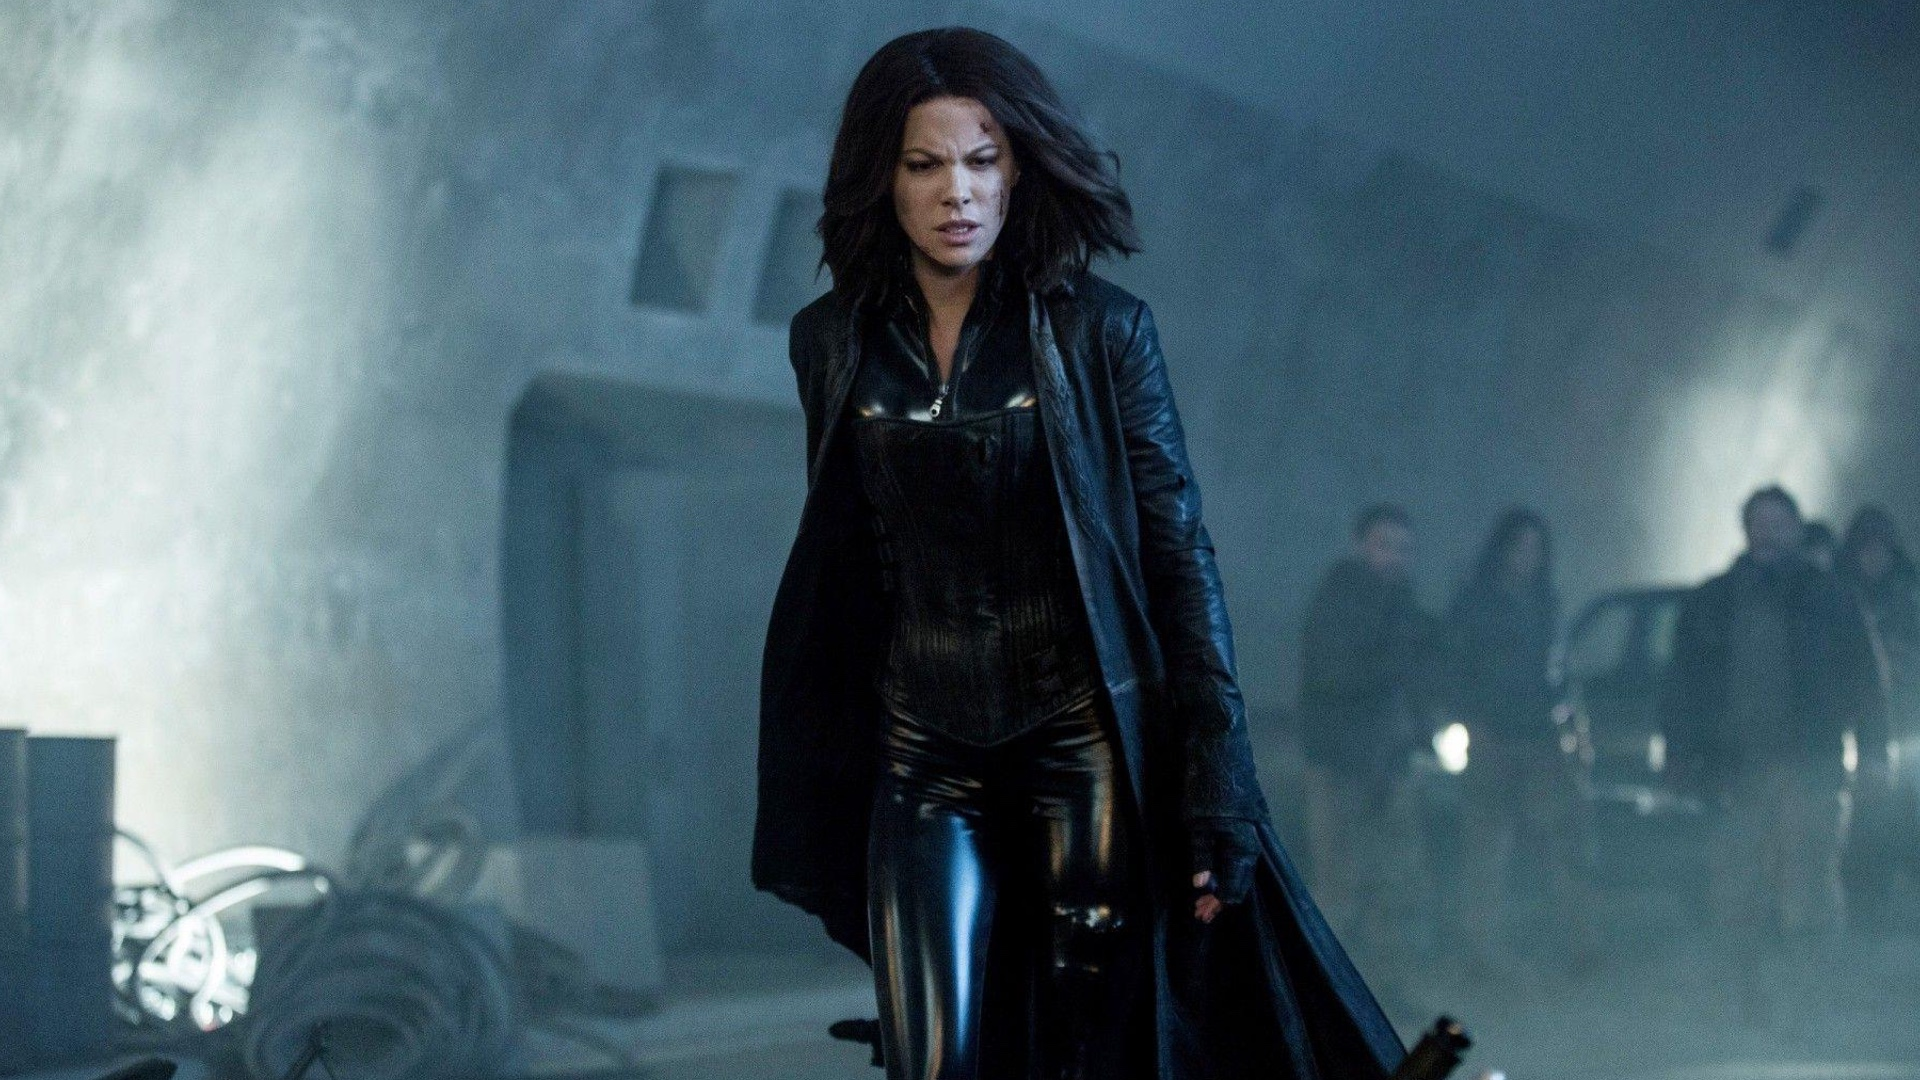Imagine a backstory for one of the indistinct figures in the background. In the murky depths of the industrial setting, one of the indistinct figures is Viktor, a seasoned vampire warrior who has seen centuries of warfare. Viktor remains in the shadows, observing Selene with a mixture of pride and concern. Once a revered leader of the vampire coven, he has now become a guardian, watching over the new generation of fighters from the sidelines. His presence in the background signifies his lingering influence and the weight of past battles that continue to shape the present struggles. What might Viktor be thinking as he watches Selene? Viktor's thoughts are a whirlwind of emotions as he watches Selene. He is filled with pride seeing her strength and determination, qualities that make her an exceptional warrior. Yet, he is also burdened by a deep concern for her safety, acutely aware of the dangers she faces. Memories of past battles and fallen comrades flood his mind, reminding him of the sacrifices that come with their eternal war. Viktor hopes that Selene's resolve will guide her through the challenges ahead, but a part of him fears the toll this relentless fight takes on her soul. 